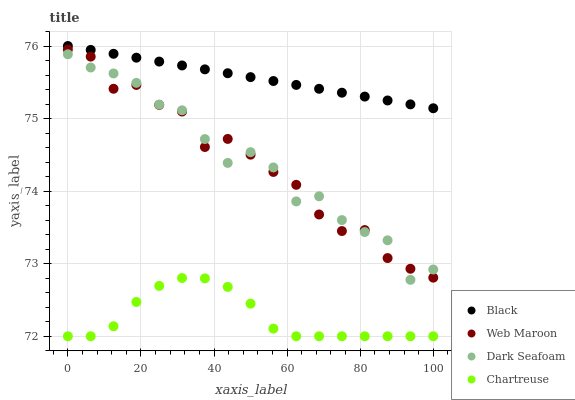Does Chartreuse have the minimum area under the curve?
Answer yes or no. Yes. Does Black have the maximum area under the curve?
Answer yes or no. Yes. Does Dark Seafoam have the minimum area under the curve?
Answer yes or no. No. Does Dark Seafoam have the maximum area under the curve?
Answer yes or no. No. Is Black the smoothest?
Answer yes or no. Yes. Is Dark Seafoam the roughest?
Answer yes or no. Yes. Is Dark Seafoam the smoothest?
Answer yes or no. No. Is Black the roughest?
Answer yes or no. No. Does Chartreuse have the lowest value?
Answer yes or no. Yes. Does Dark Seafoam have the lowest value?
Answer yes or no. No. Does Black have the highest value?
Answer yes or no. Yes. Does Dark Seafoam have the highest value?
Answer yes or no. No. Is Chartreuse less than Web Maroon?
Answer yes or no. Yes. Is Black greater than Web Maroon?
Answer yes or no. Yes. Does Dark Seafoam intersect Web Maroon?
Answer yes or no. Yes. Is Dark Seafoam less than Web Maroon?
Answer yes or no. No. Is Dark Seafoam greater than Web Maroon?
Answer yes or no. No. Does Chartreuse intersect Web Maroon?
Answer yes or no. No. 